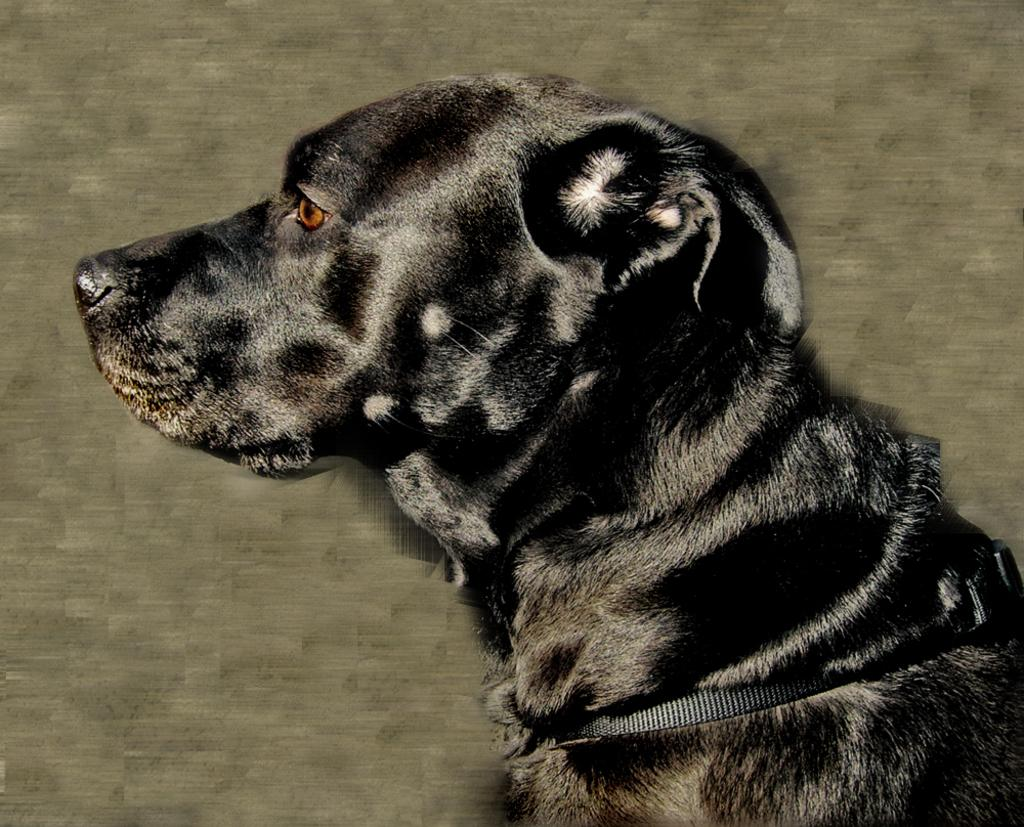What type of animal is present in the image? There is a black color dog in the image. What other object can be seen in the image? There is a black color belt in the image. What type of straw is visible in the image? There is no straw present in the image. What is the limit of the dog's ability to move in the image? The image does not depict any limitations on the dog's movement, and the concept of a "limit" is not applicable to the image. 